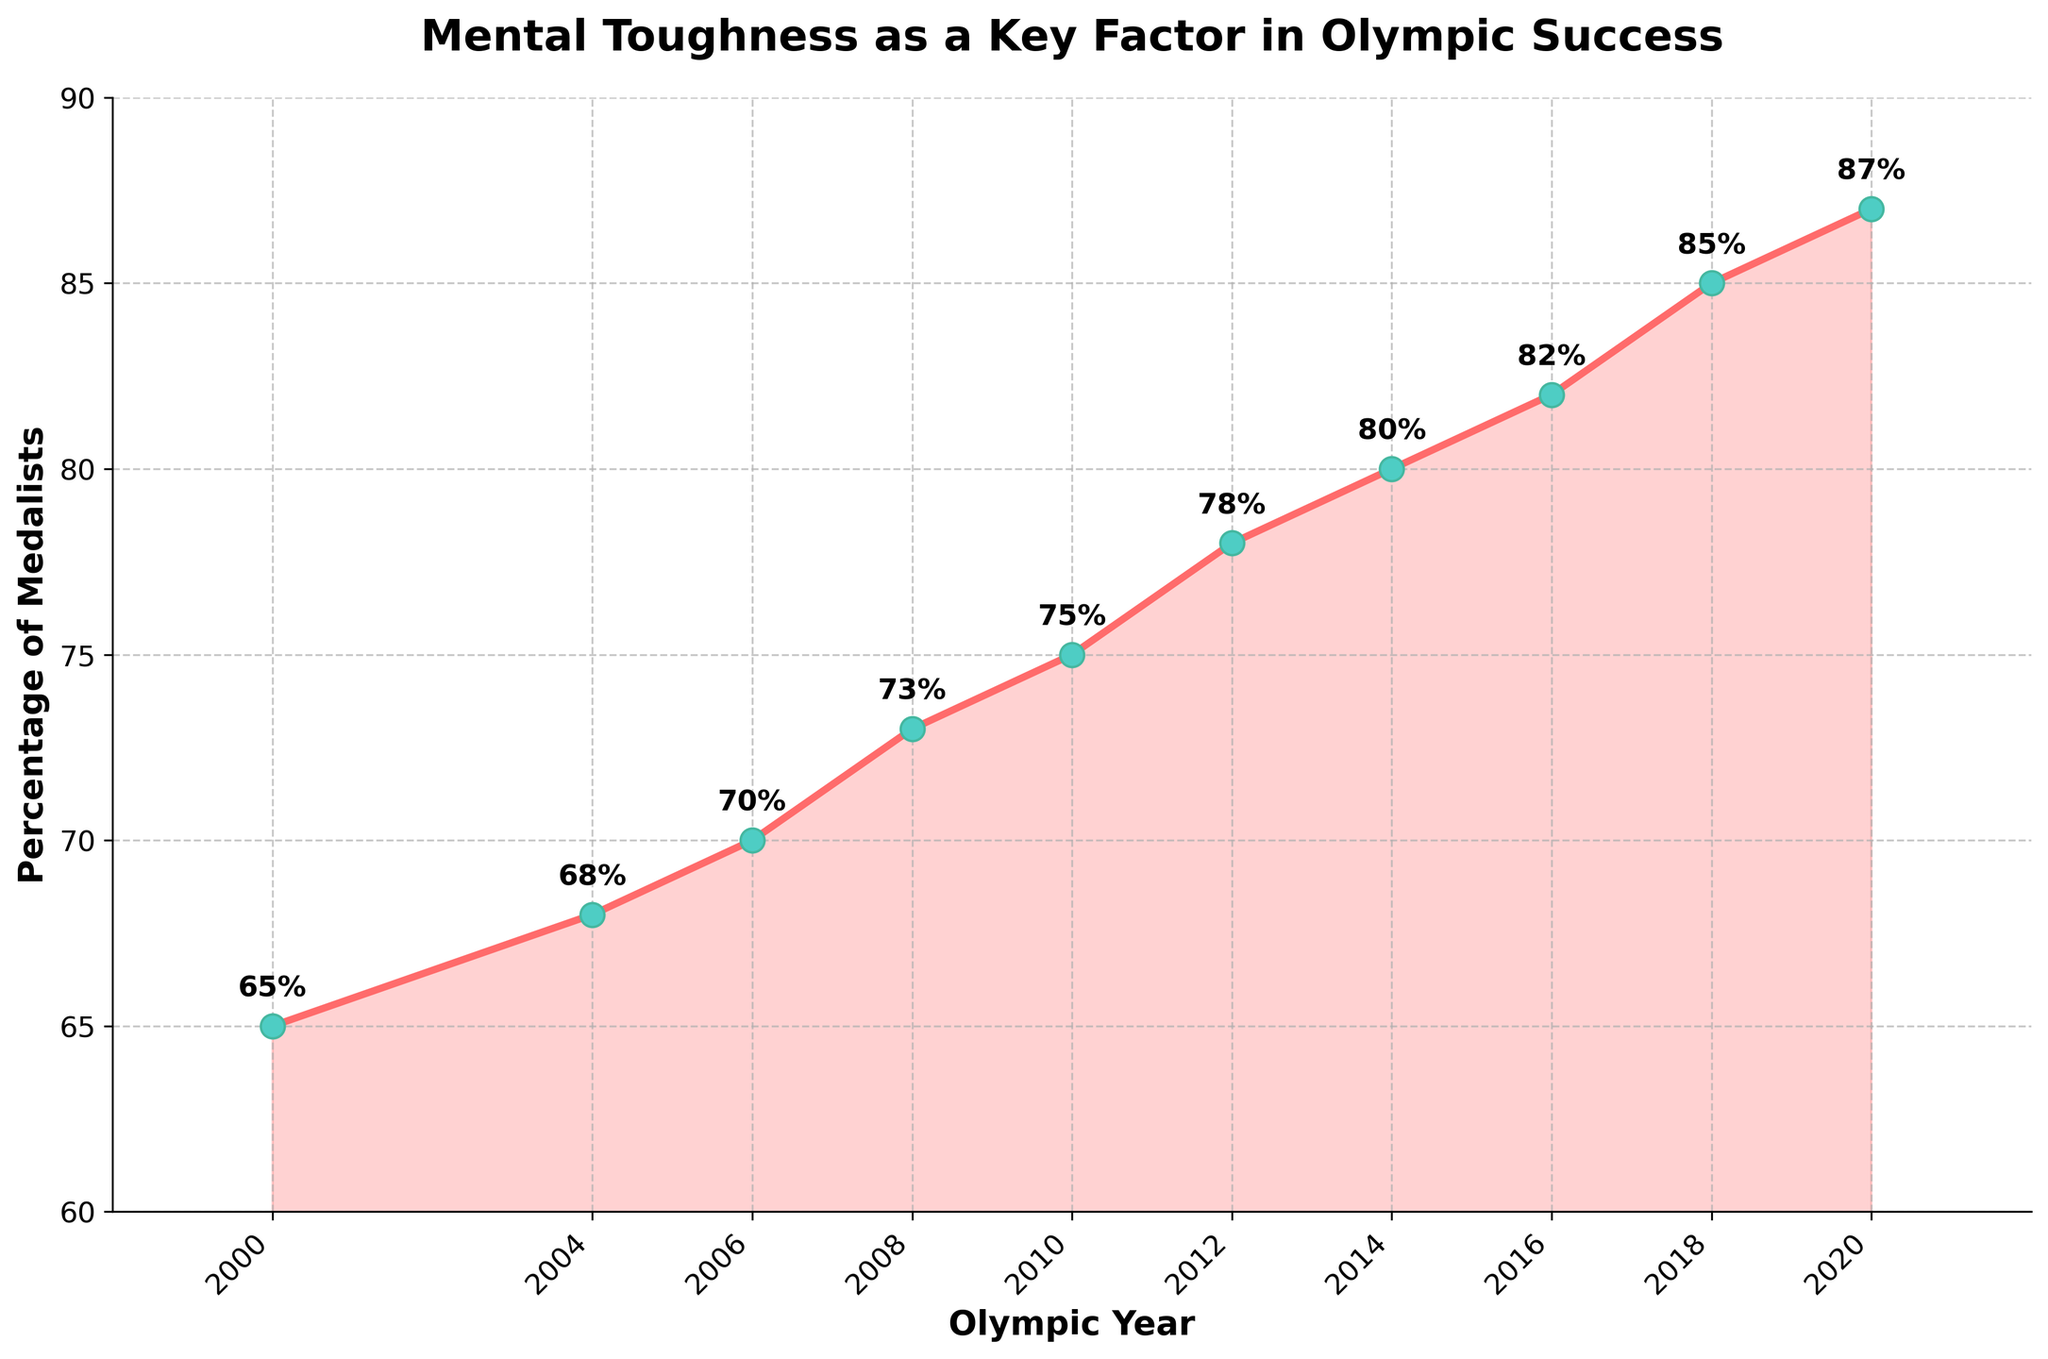What is the percentage of medalists crediting mental toughness in the 2020 Tokyo Olympics? To answer this, look at the data point for the 2020 Tokyo Olympics on the plot. The figure shows a value annotated as 87%.
Answer: 87% Which Olympic Games saw the highest percentage of medalists crediting mental toughness? To determine this, examine all the data points on the plot and identify the highest percentage value. The highest annotation is 87%, corresponding to the 2020 Tokyo Olympics.
Answer: 2020 Tokyo Which year had a greater percentage of medalists crediting mental toughness: 2012 or 2016? Examine the data points for the 2012 London and 2016 Rio Olympics. The annotated values for these years are 78% and 82%, respectively. Since 82 is greater than 78, 2016 had a greater percentage.
Answer: 2016 What is the difference in the percentage of medalists crediting mental toughness between the 2000 Sydney and 2020 Tokyo Olympics? Identify the percentage values for the 2000 Sydney and 2020 Tokyo Olympics, which are 65% and 87%, respectively. Subtract the smaller value from the larger value (87 - 65 = 22).
Answer: 22% During which Olympic Games did the percentage of medalists crediting mental toughness first exceed 80%? Look for the first data point on the plot where the annotated percentage exceeds 80%. The percentage first exceeds 80% during the 2014 Sochi Olympics.
Answer: 2014 Sochi What is the average percentage of medalists crediting mental toughness across all ten Olympic Games shown? Sum all the percentages from the data points: 65 + 68 + 70 + 73 + 75 + 78 + 80 + 82 + 85 + 87 = 763. Divide this sum by the number of data points (10). 763 / 10 = 76.3%.
Answer: 76.3% What is the trend in the percentage of medalists crediting mental toughness as you move from the 2000 Sydney Olympics to the 2020 Tokyo Olympics? Observe the general direction of the line connecting the data points from 2000 to 2020. The line shows an upward trend, indicating an increase in the percentage over time.
Answer: Increasing Which Olympic Games had the smallest increase in the percentage of medalists crediting mental toughness from the previous games? Calculate the percentage differences between consecutive games: 
2000 to 2004: 68 - 65 = 3%, 
2004 to 2006: 70 - 68 = 2%, 
2006 to 2008: 73 - 70 = 3%, 
2008 to 2010: 75 - 73 = 2%, 
2010 to 2012: 78 - 75 = 3%, 
2012 to 2014: 80 - 78 = 2%, 
2014 to 2016: 82 - 80 = 2%, 
2016 to 2018: 85 - 82 = 3%, 
2018 to 2020: 87 - 85 = 2%.
The smallest increase is 2%, occurring four times. After further analysis, the first occurrence is from 2004 to 2006 Turin.
Answer: 2006 Turin 